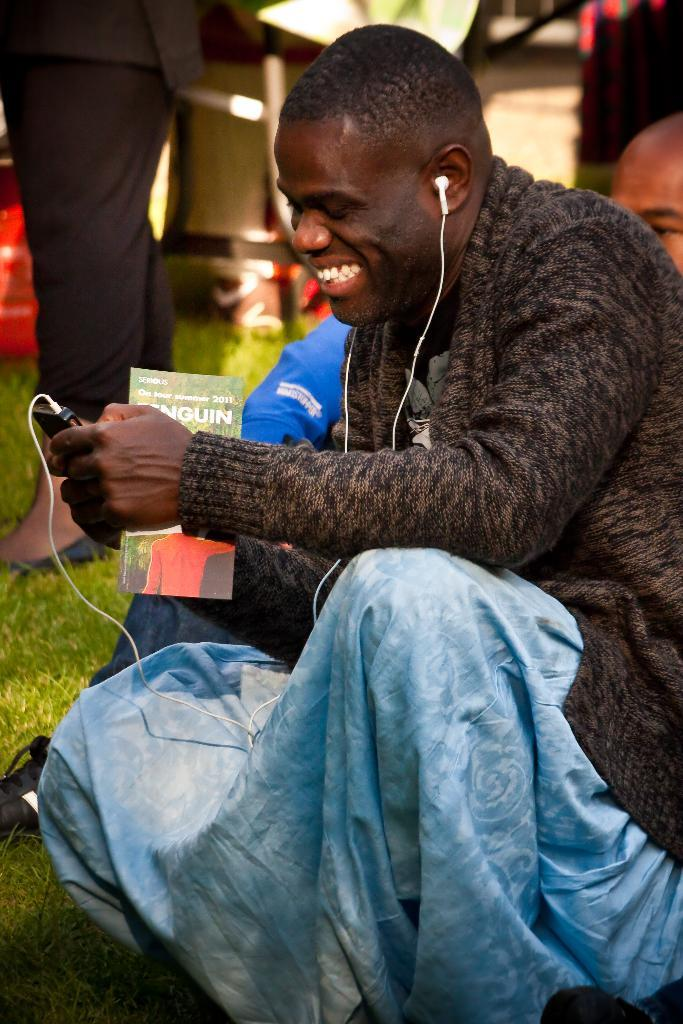What is the man in the image doing? There is a man sitting on the ground in the image. What object is the man holding in his hand? The man is holding a mobile phone in his hand. Can you describe the other person visible in the image? There is another man wearing a black suit visible in the background of the image, and he is standing. What type of rifle is the man holding in the image? There is no rifle present in the image; the man is holding a mobile phone. What do you believe the man is thinking while sitting on the ground? We cannot determine what the man is thinking from the image alone, as thoughts are not visible. 